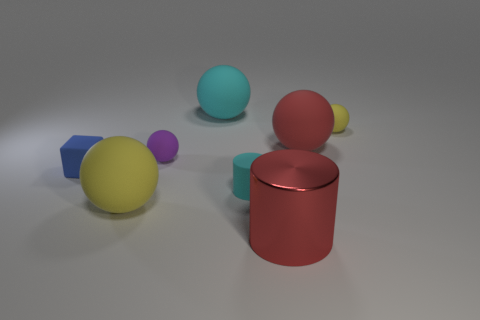Is there any other thing that is the same color as the metal cylinder?
Your response must be concise. Yes. What is the color of the large matte sphere that is in front of the blue object?
Your answer should be very brief. Yellow. Is the color of the tiny ball left of the big red matte ball the same as the tiny cube?
Provide a short and direct response. No. There is a small cyan thing that is the same shape as the big shiny object; what is it made of?
Give a very brief answer. Rubber. How many red metallic things have the same size as the cyan cylinder?
Make the answer very short. 0. What is the shape of the small purple thing?
Offer a very short reply. Sphere. There is a object that is on the right side of the small cylinder and in front of the purple thing; how big is it?
Give a very brief answer. Large. What is the yellow sphere that is left of the big cyan rubber thing made of?
Ensure brevity in your answer.  Rubber. Is the color of the metal object the same as the small sphere that is to the right of the large red cylinder?
Offer a very short reply. No. What number of things are either yellow matte objects left of the cyan rubber ball or cyan cylinders that are in front of the small yellow rubber object?
Provide a succinct answer. 2. 